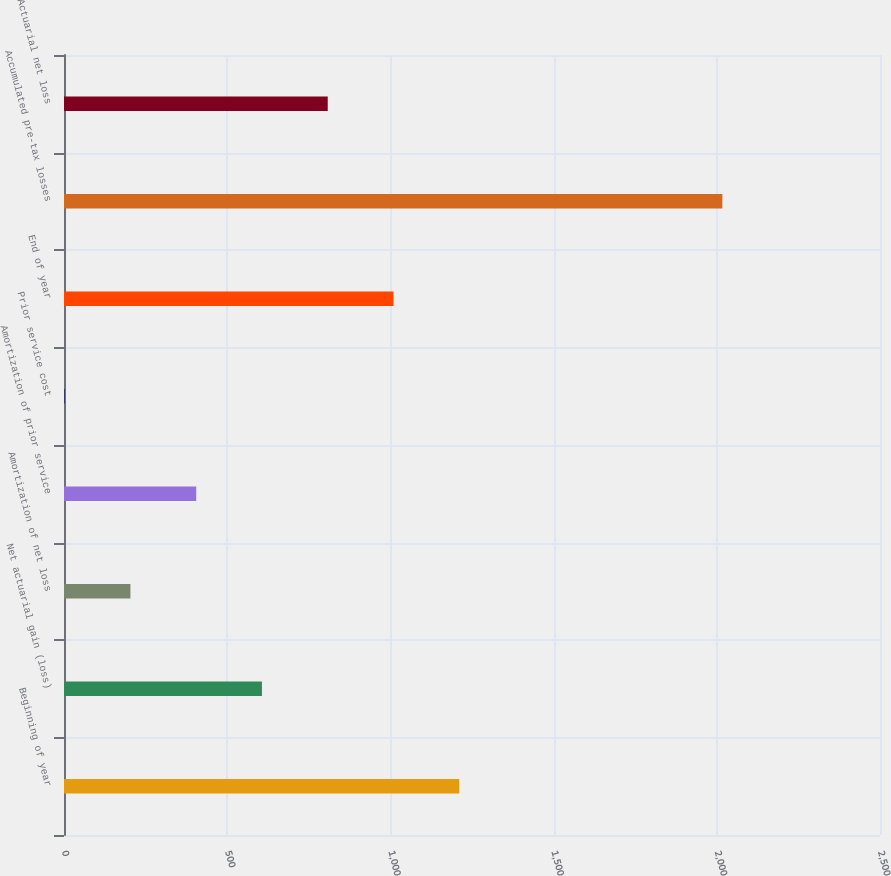Convert chart. <chart><loc_0><loc_0><loc_500><loc_500><bar_chart><fcel>Beginning of year<fcel>Net actuarial gain (loss)<fcel>Amortization of net loss<fcel>Amortization of prior service<fcel>Prior service cost<fcel>End of year<fcel>Accumulated pre-tax losses<fcel>Actuarial net loss<nl><fcel>1211<fcel>606.5<fcel>203.5<fcel>405<fcel>2<fcel>1009.5<fcel>2017<fcel>808<nl></chart> 